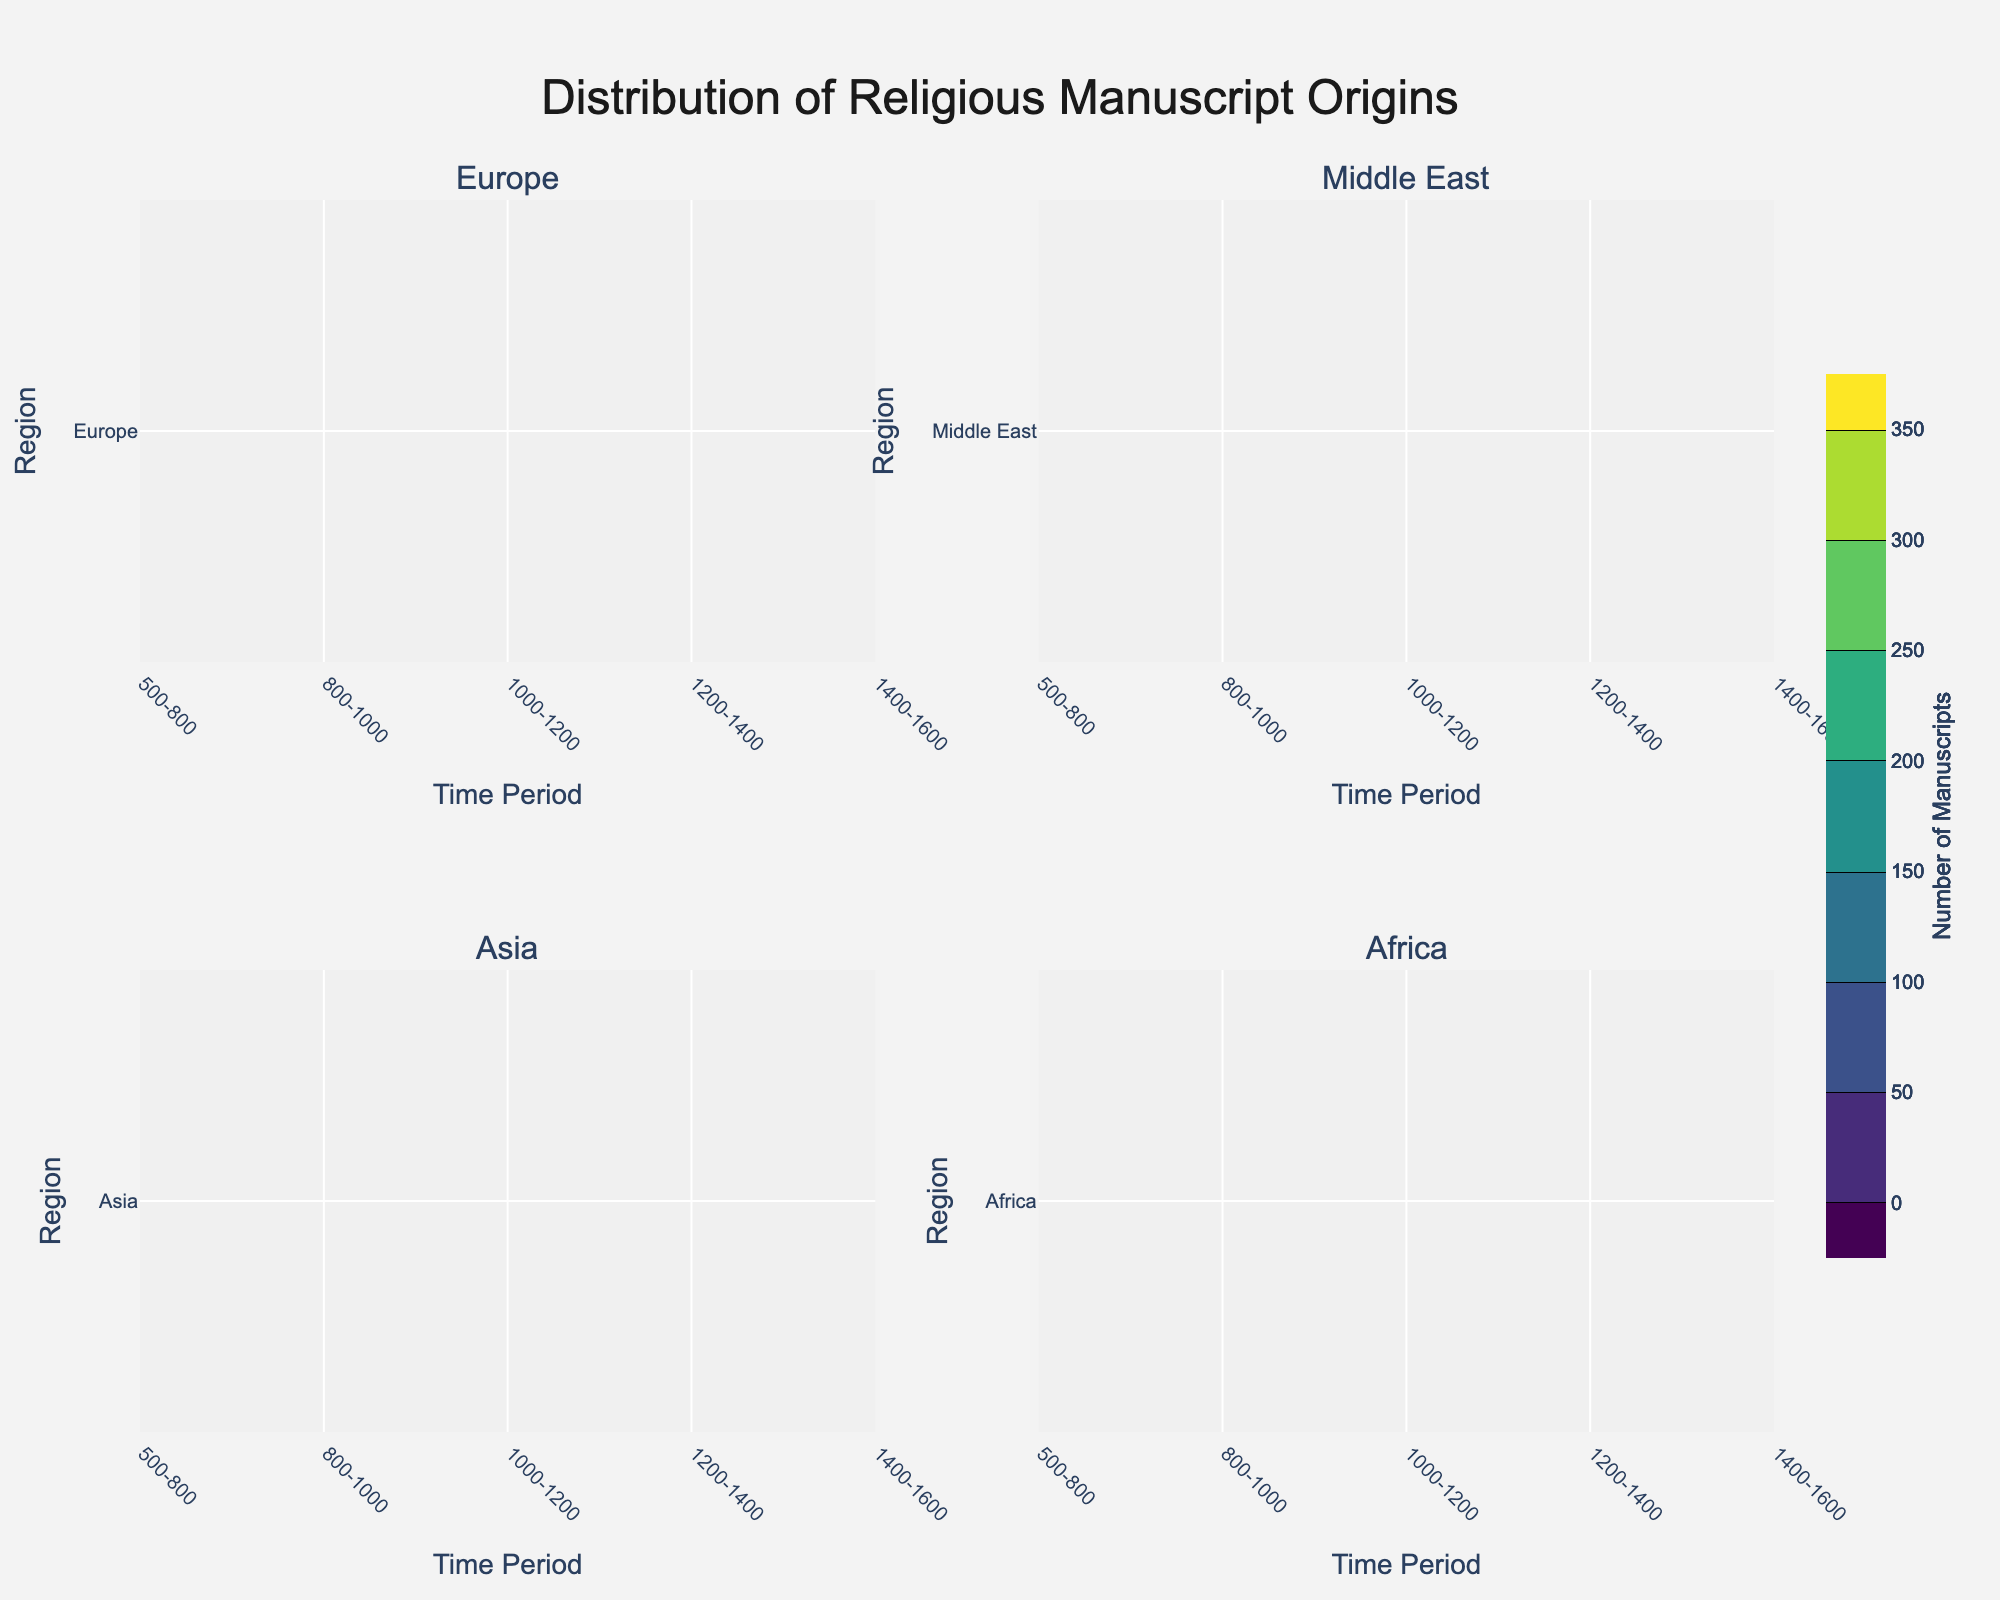What is the title of this figure? The title is usually placed at the top of the figure, and it summarizes the overall content. The title of this figure is "Distribution of Religious Manuscript Origins."
Answer: Distribution of Religious Manuscript Origins Which region has the highest number of manuscripts between 1400 and 1600? By looking at the contour plots, it is evident from the color intensity that Europe has the highest number of manuscripts during the period 1400-1600 compared to other regions.
Answer: Europe In which time period did the Middle East see a significant increase in the number of manuscripts? Comparing the contour plots for the Middle East across time periods, a notable increase can be observed between 800-1000 AD. The difference in color intensity from the previous period indicates a significant increase in the number of manuscripts.
Answer: 800-1000 Which region has the least number of manuscripts in the period 500-800? By analyzing the contour plots, we can see that Africa shows the least number of manuscripts in the period 500-800, as indicated by the color intensity.
Answer: Africa How does the number of manuscripts in Asia between 1000-1200 compare to the number in Middle East during the same period? By looking at the contour plots for Asia and the Middle East during 1000-1200, we observe that the color intensity for Asia is less compared to the Middle East, indicating fewer manuscripts in Asia.
Answer: Fewer in Asia In which time period did Europe have around 200 manuscripts? Observing the contour plot for Europe, we see that around 200 manuscripts are present in the period between 800-1000, indicated by the corresponding color intensity and contour labeling.
Answer: 800-1000 What is the overall trend in the number of manuscripts in Africa across the time periods shown? Analyzing the contour plots for Africa, we notice a gradually increasing trend in the number of manuscripts across the time periods from 500-800 to 1400-1600 as the color intensity increases over time.
Answer: Increasing Which region shows the most diverse changes in the number of manuscripts over time? Comparing the contour plots of all regions, Europe shows the most dynamic changes in the number of manuscripts over time, as evidenced by the broader range of color intensities and more distinct contour lines.
Answer: Europe 